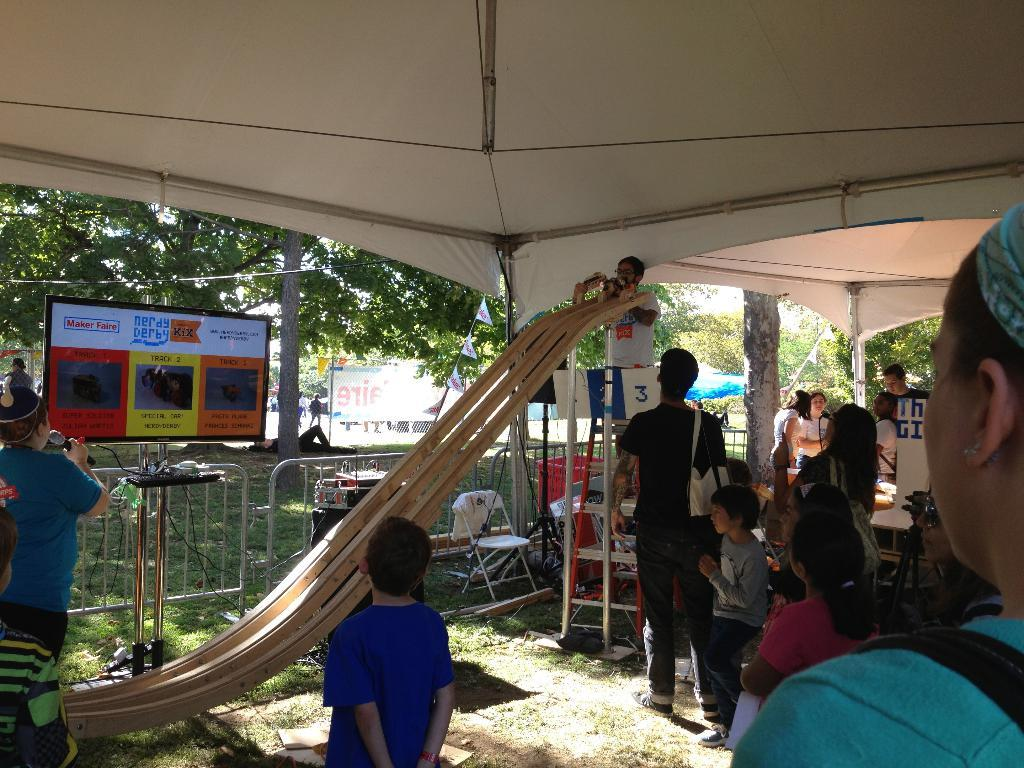How many people can be seen in the image? There are many people in the image. What can be found in the middle of the image? There are trees, a ladder, and boards in the middle of the image. Are there any cherries hanging from the trees in the image? There is no mention of cherries in the image, so we cannot determine if they are present or not. Can you see a cave in the background of the image? There is no mention of a cave in the image, so we cannot determine if it is present or not. 